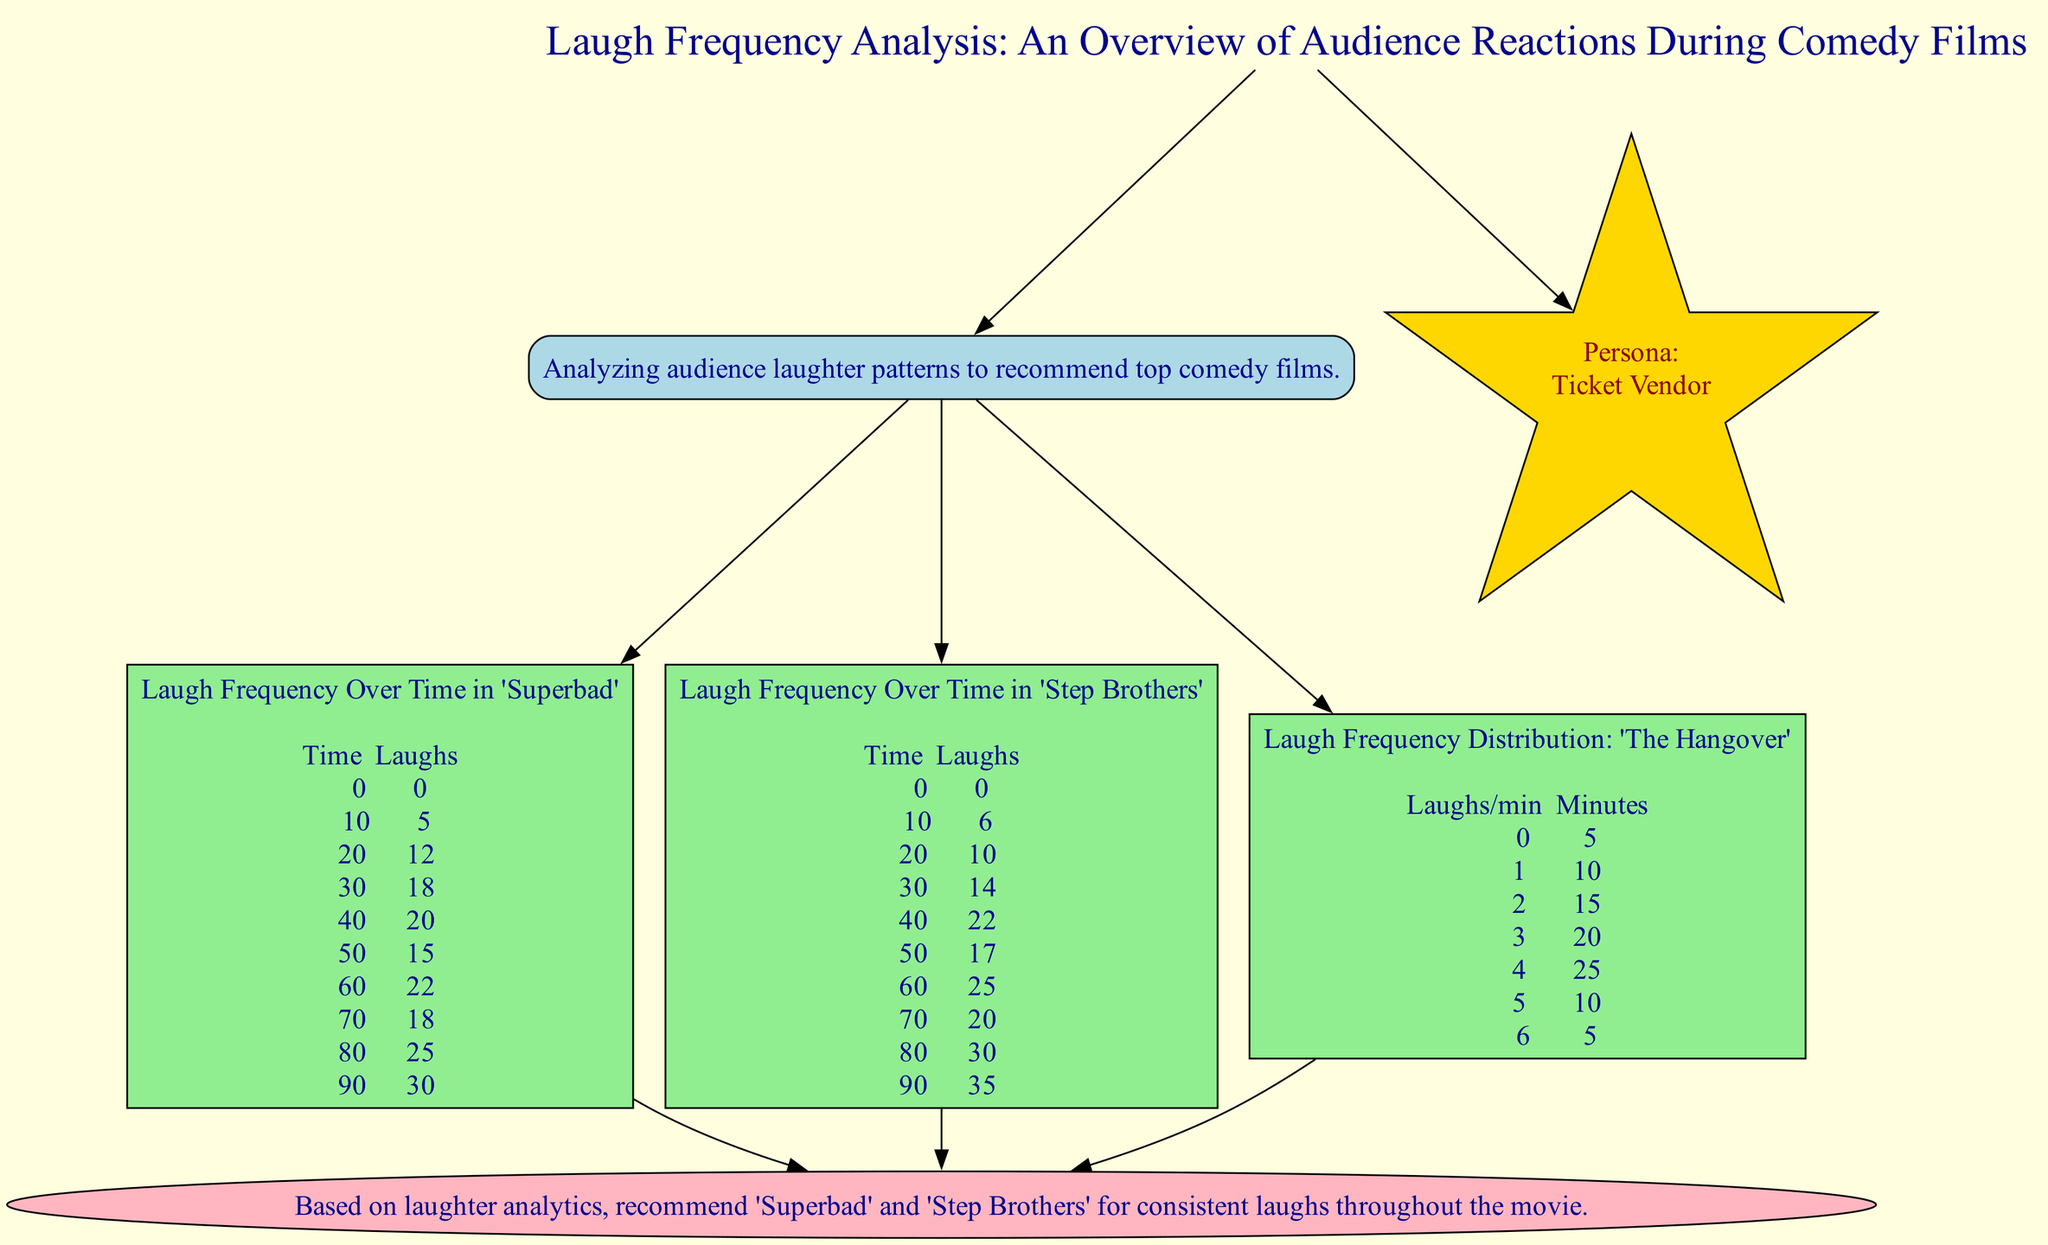What is the peak number of laughs in 'Step Brothers'? By examining the data provided in the line graph for 'Step Brothers', the peak occurs at 90 minutes with 35 laughs recorded.
Answer: 35 What time did 'Superbad' achieve its highest laugh frequency? Referring to the 'Superbad' line graph, the highest laugh count of 30 occurs at 90 minutes into the film.
Answer: 90 minutes How many laughs were recorded at 40 minutes in 'Superbad'? Looking at the specific data point for 'Superbad', at 40 minutes the recorded laughs total 20.
Answer: 20 Which film shows consistent laughs throughout its duration also indicated by laughter analytics? Based on the insight section at the bottom of the diagram, both 'Superbad' and 'Step Brothers' are recommended for consistent laughs.
Answer: 'Superbad' and 'Step Brothers' What is the number of minutes where there were 4 laughs per minute in 'The Hangover'? Referring to the histogram data for 'The Hangover', there are 25 minutes where the frequency of laughs per minute is 4.
Answer: 25 minutes How many laughs were recorded at 60 minutes in 'Step Brothers'? By examining the line graph data for 'Step Brothers', at the 60-minute mark there were 25 laughs noted.
Answer: 25 In the introduction section, what is the primary focus of this analysis? The introduction content mentions that the analysis is focused on analyzing audience laughter patterns to recommend top comedy films.
Answer: Analyzing audience laughter patterns What laugh frequency corresponds to the longest duration in 'The Hangover'? The longest duration on the histogram is for 3 laughs per minute, occurring over 20 minutes, which is the most significant time segment.
Answer: 20 minutes At what time does 'Superbad' show a drop in laughs after peaking? From the data for 'Superbad', after the peak at 90 minutes, there is a noticeable drop in laughs recorded at 80 minutes, where it sees a decrease to 25 laughs.
Answer: 80 minutes 